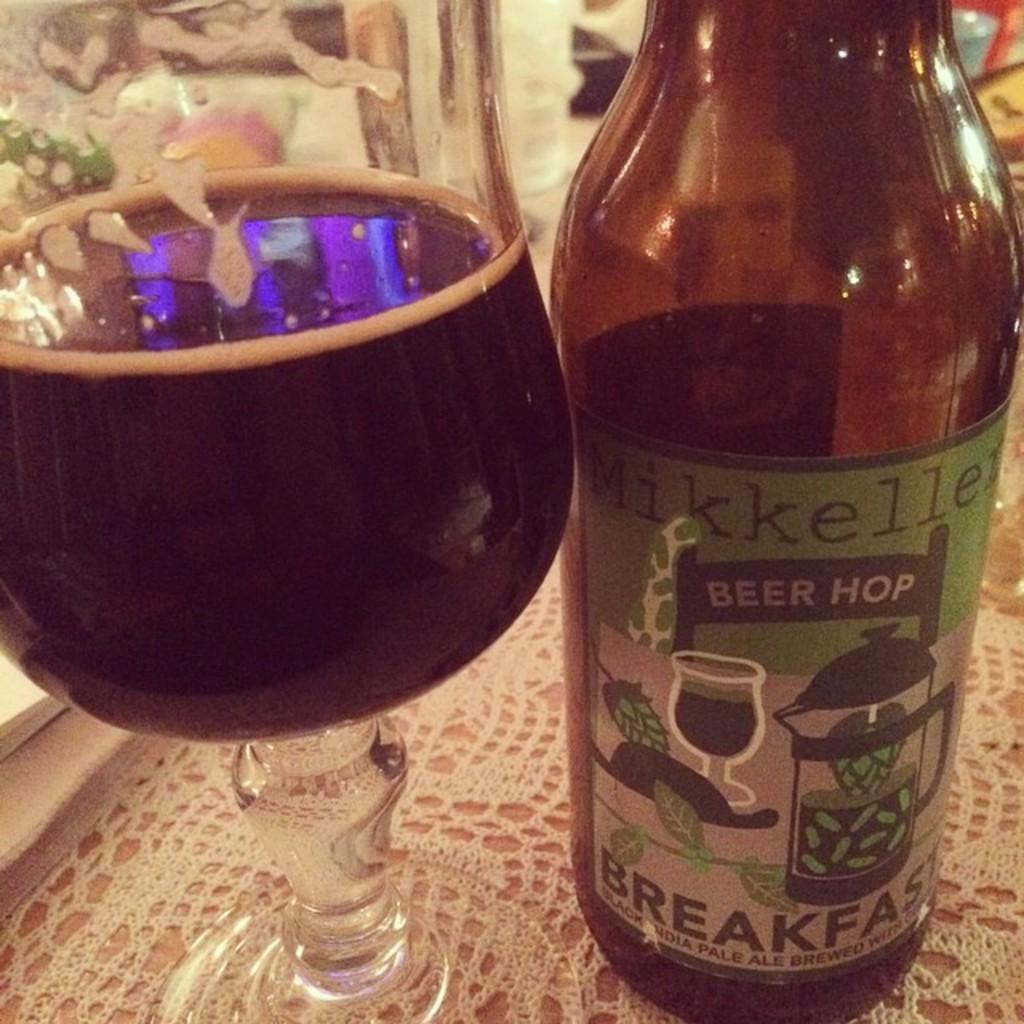When should the drink be consumed?
Keep it short and to the point. Breakfast. What meal is listed on the bottle?
Provide a short and direct response. Breakfast. 